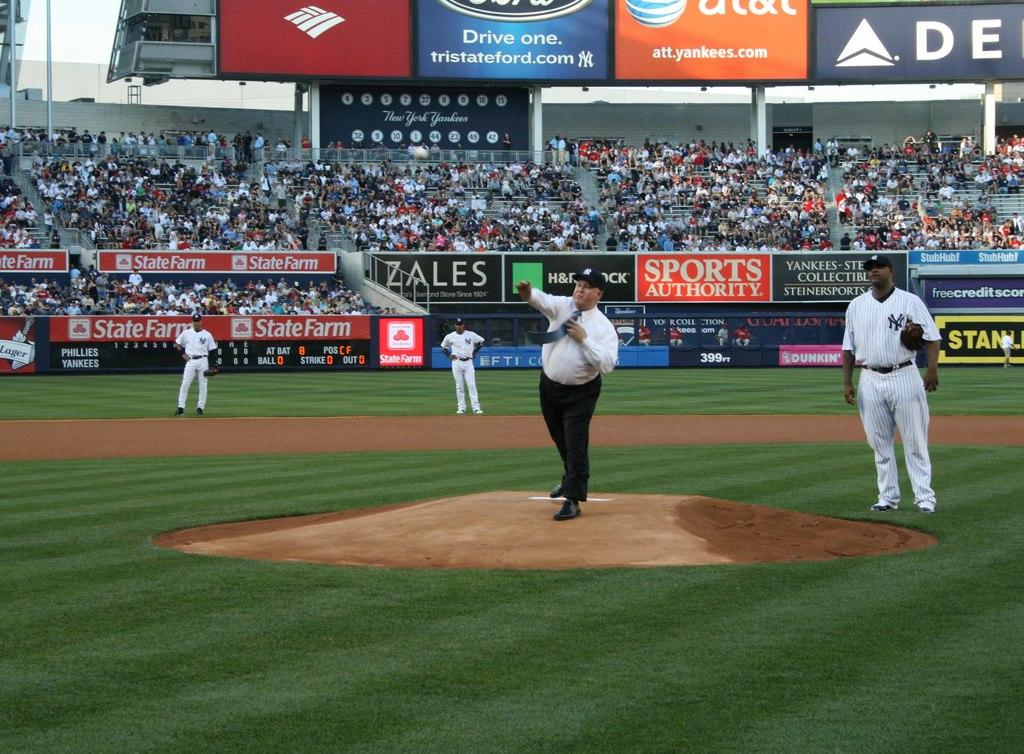Provide a one-sentence caption for the provided image. An overweight man wearing a tie throw the pitch on the field with ads like at&t. 